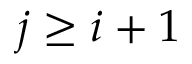Convert formula to latex. <formula><loc_0><loc_0><loc_500><loc_500>j \geq i + 1</formula> 